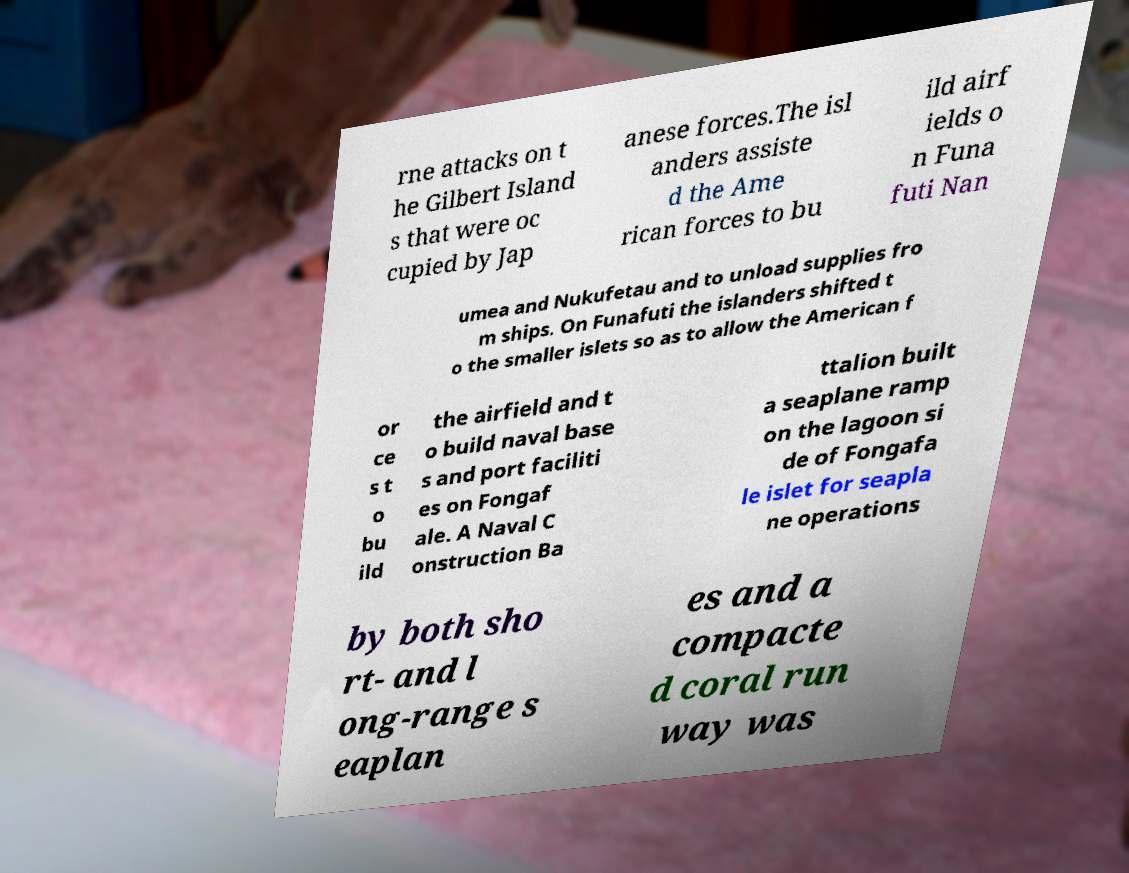Could you extract and type out the text from this image? rne attacks on t he Gilbert Island s that were oc cupied by Jap anese forces.The isl anders assiste d the Ame rican forces to bu ild airf ields o n Funa futi Nan umea and Nukufetau and to unload supplies fro m ships. On Funafuti the islanders shifted t o the smaller islets so as to allow the American f or ce s t o bu ild the airfield and t o build naval base s and port faciliti es on Fongaf ale. A Naval C onstruction Ba ttalion built a seaplane ramp on the lagoon si de of Fongafa le islet for seapla ne operations by both sho rt- and l ong-range s eaplan es and a compacte d coral run way was 